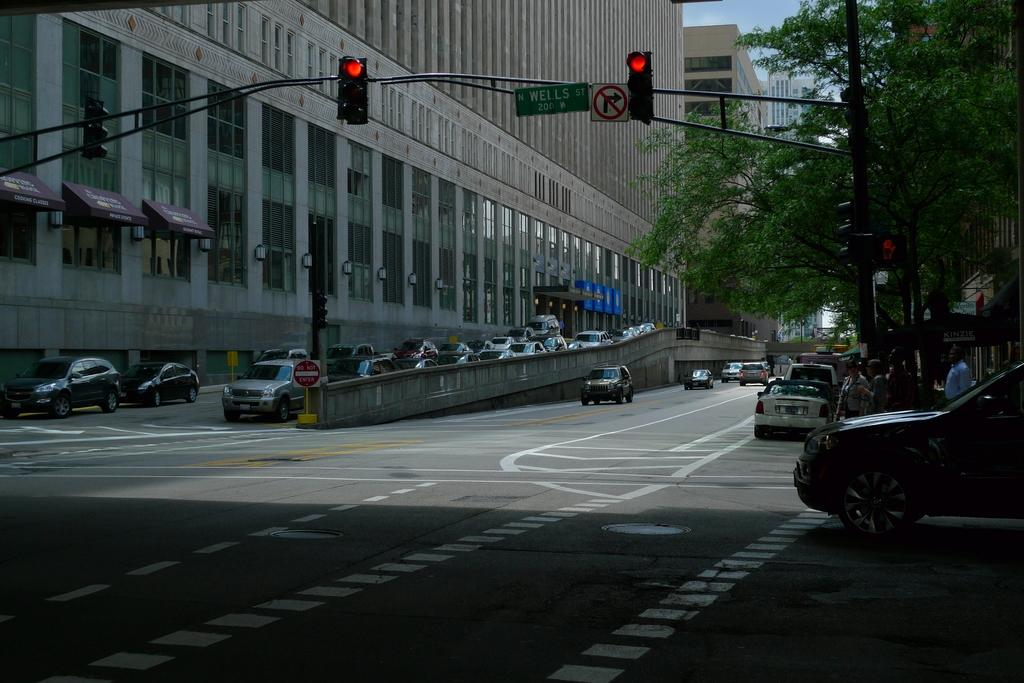<image>
Offer a succinct explanation of the picture presented. A black car is stopped at the intersection of North Wells Street. 